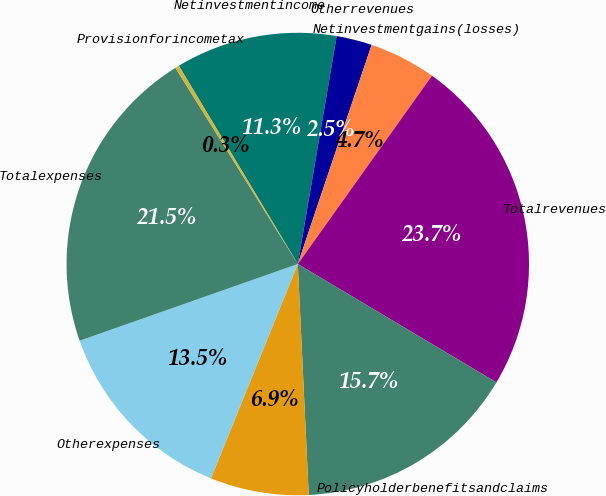Convert chart. <chart><loc_0><loc_0><loc_500><loc_500><pie_chart><fcel>Netinvestmentincome<fcel>Otherrevenues<fcel>Netinvestmentgains(losses)<fcel>Totalrevenues<fcel>Policyholderbenefitsandclaims<fcel>Unnamed: 5<fcel>Otherexpenses<fcel>Totalexpenses<fcel>Provisionforincometax<nl><fcel>11.29%<fcel>2.48%<fcel>4.68%<fcel>23.7%<fcel>15.69%<fcel>6.88%<fcel>13.49%<fcel>21.5%<fcel>0.28%<nl></chart> 